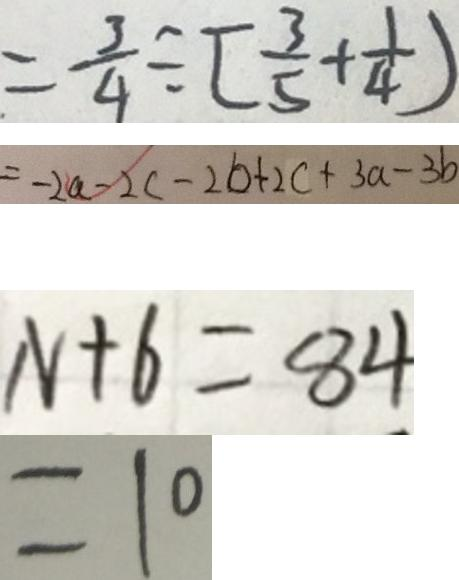Convert formula to latex. <formula><loc_0><loc_0><loc_500><loc_500>= \frac { 3 } { 4 } \div [ \frac { 3 } { 5 } + \frac { 1 } { 4 } ) 
 = - 2 a - 2 c - 2 b + 2 c + 3 a - 3 b 
 N + 6 = 8 4 
 = 1 0</formula> 